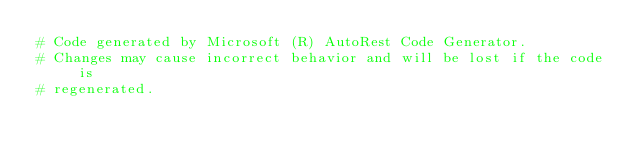<code> <loc_0><loc_0><loc_500><loc_500><_Ruby_># Code generated by Microsoft (R) AutoRest Code Generator.
# Changes may cause incorrect behavior and will be lost if the code is
# regenerated.
</code> 